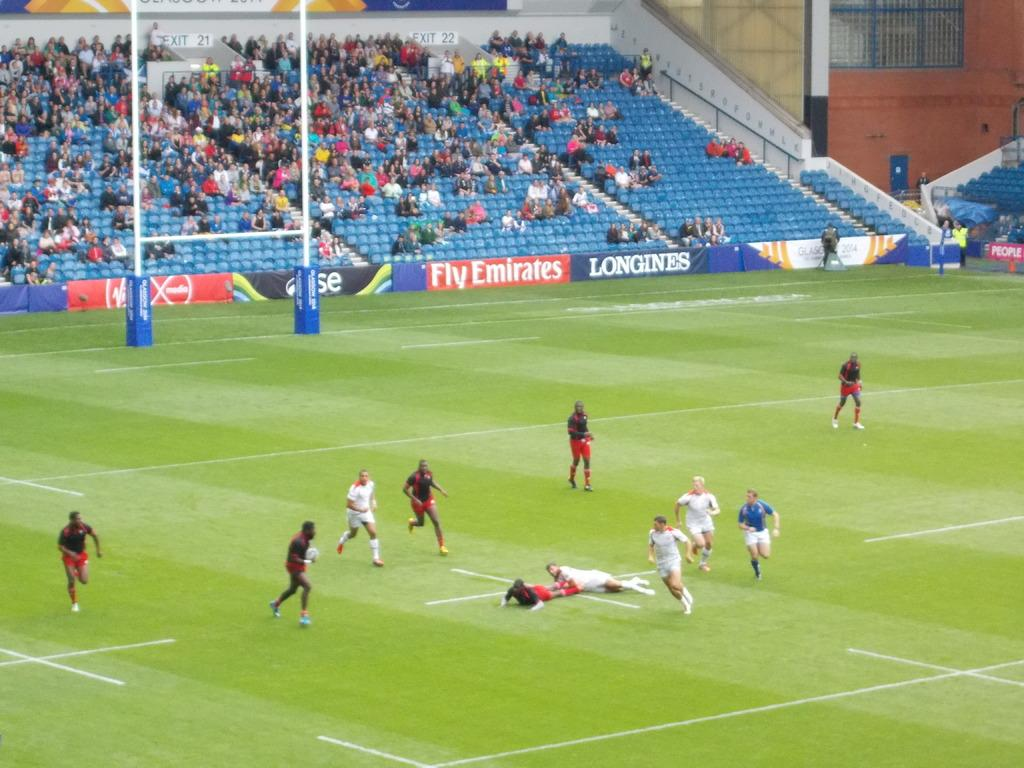Provide a one-sentence caption for the provided image. Two teams out on a field with a Fly Emirates advertisement sign shown behind them. 